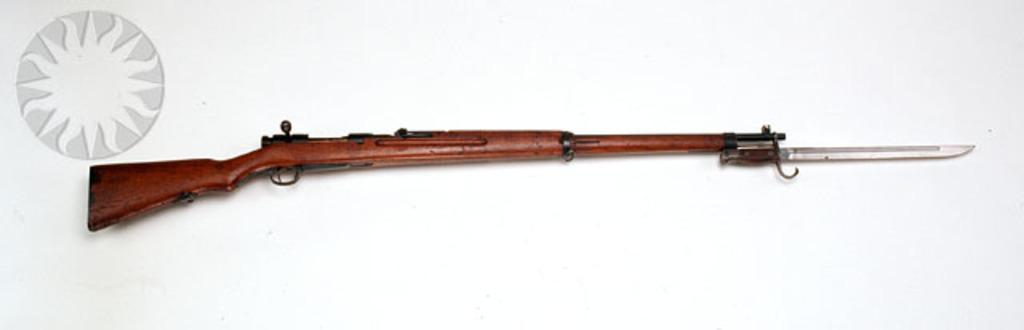What object is the main focus of the image? There is a gun in the image. Can you describe the appearance of the gun? The gun is brown and black in color. What is the gun placed on in the image? The gun is on a white colored surface. Are there any other objects related to the gun in the image? Yes, there is a knife in the image. Where is the knife positioned in relation to the gun? The knife is to the right end of the gun. Is the gun sinking in quicksand in the image? No, the gun is not sinking in quicksand in the image; it is placed on a white colored surface. How many tomatoes are on the gun in the image? There are no tomatoes present in the image. 